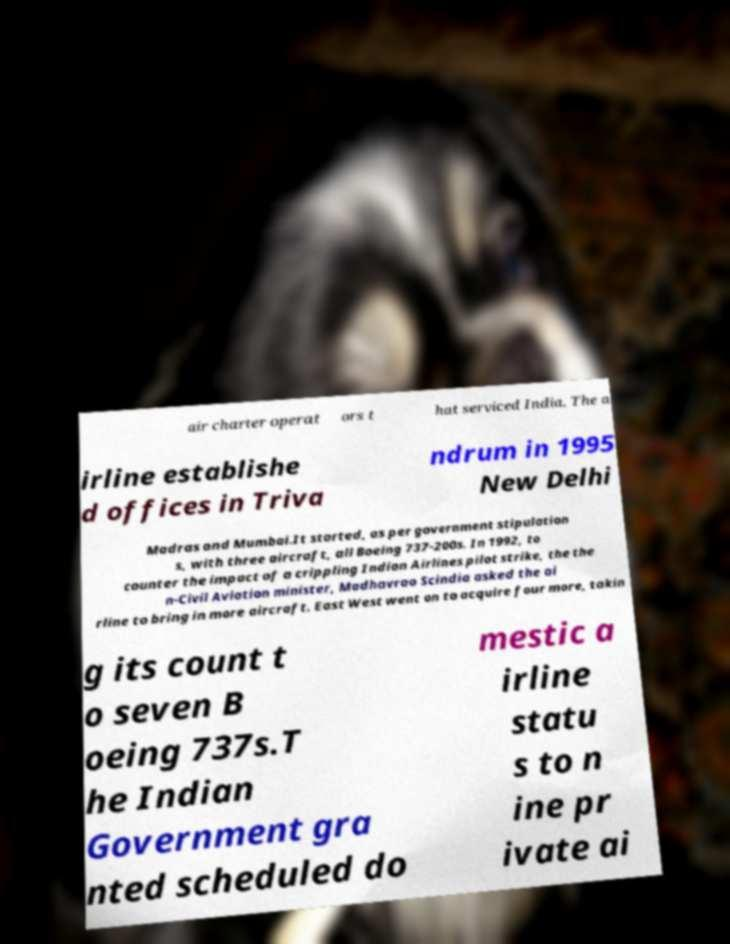There's text embedded in this image that I need extracted. Can you transcribe it verbatim? air charter operat ors t hat serviced India. The a irline establishe d offices in Triva ndrum in 1995 New Delhi Madras and Mumbai.It started, as per government stipulation s, with three aircraft, all Boeing 737-200s. In 1992, to counter the impact of a crippling Indian Airlines pilot strike, the the n-Civil Aviation minister, Madhavrao Scindia asked the ai rline to bring in more aircraft. East West went on to acquire four more, takin g its count t o seven B oeing 737s.T he Indian Government gra nted scheduled do mestic a irline statu s to n ine pr ivate ai 